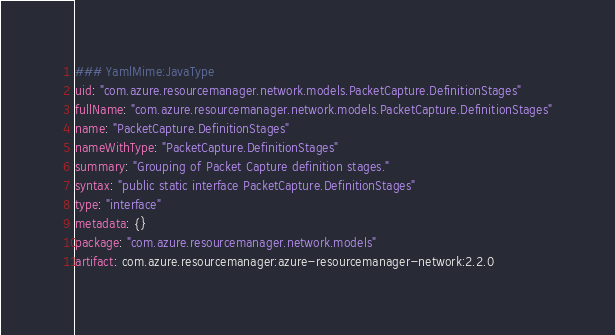<code> <loc_0><loc_0><loc_500><loc_500><_YAML_>### YamlMime:JavaType
uid: "com.azure.resourcemanager.network.models.PacketCapture.DefinitionStages"
fullName: "com.azure.resourcemanager.network.models.PacketCapture.DefinitionStages"
name: "PacketCapture.DefinitionStages"
nameWithType: "PacketCapture.DefinitionStages"
summary: "Grouping of Packet Capture definition stages."
syntax: "public static interface PacketCapture.DefinitionStages"
type: "interface"
metadata: {}
package: "com.azure.resourcemanager.network.models"
artifact: com.azure.resourcemanager:azure-resourcemanager-network:2.2.0
</code> 